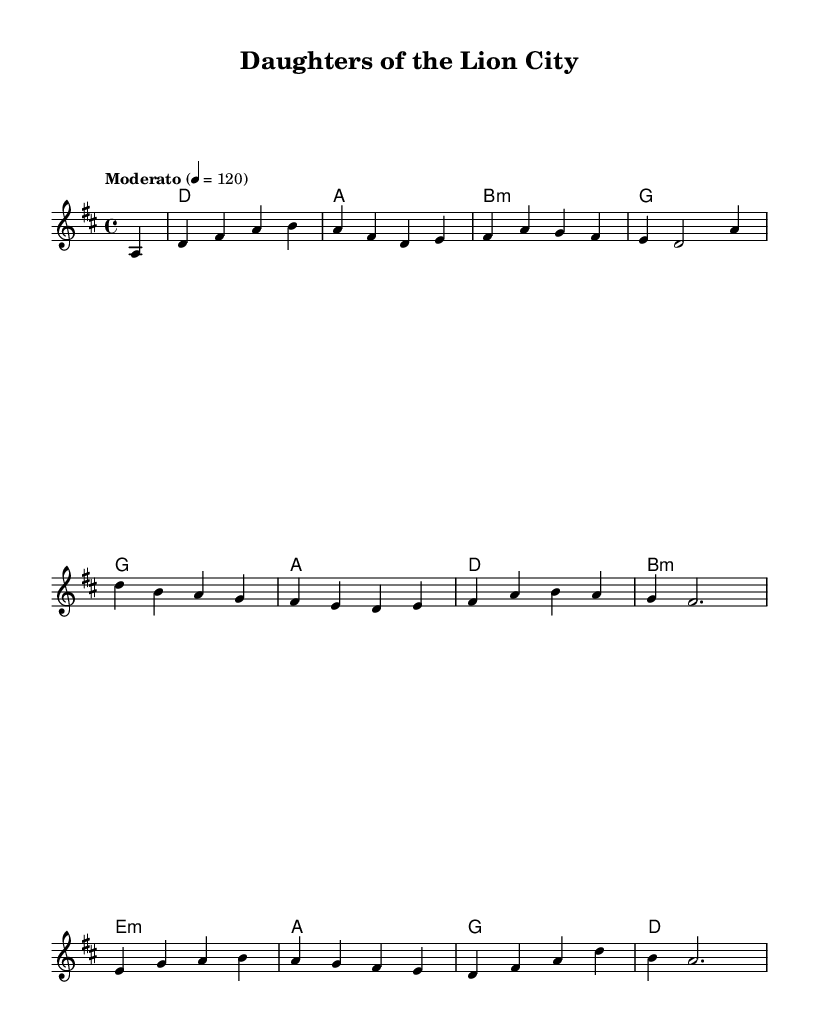What is the key signature of this music? The key signature is D major, which has two sharps (F# and C#). This is indicated at the beginning of the score.
Answer: D major What is the time signature of this music? The time signature is 4/4, which indicates there are four beats in a measure. This is found at the beginning of the score.
Answer: 4/4 What is the tempo marking for this music? The tempo marking is "Moderato," which is indicated above the staff. It generally suggests a moderate speed, specifically set to 120 beats per minute in this case.
Answer: Moderato How many measures are in the play? By counting the measures in the score, there are 12 measures total as the melody and harmonies are repeated and structured accordingly.
Answer: 12 Identify the first chord of the piece. The first chord is D major, which is the chord notated and played at the beginning of the harmonies. This establishes the tonality of the piece.
Answer: D Name the last note in the melody. The last note in the melody is A, which is the final note before the rest that completes the phrase in the context provided.
Answer: A What is the highest note in the melody? The highest note in the melody is B, found in measure 2. This is determined by identifying the pitch of each note from the beginning to the end of the melody line.
Answer: B 